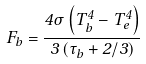<formula> <loc_0><loc_0><loc_500><loc_500>F _ { b } = \frac { 4 \sigma \left ( T _ { b } ^ { 4 } - T _ { e } ^ { 4 } \right ) } { 3 \left ( \tau _ { b } + 2 / 3 \right ) }</formula> 